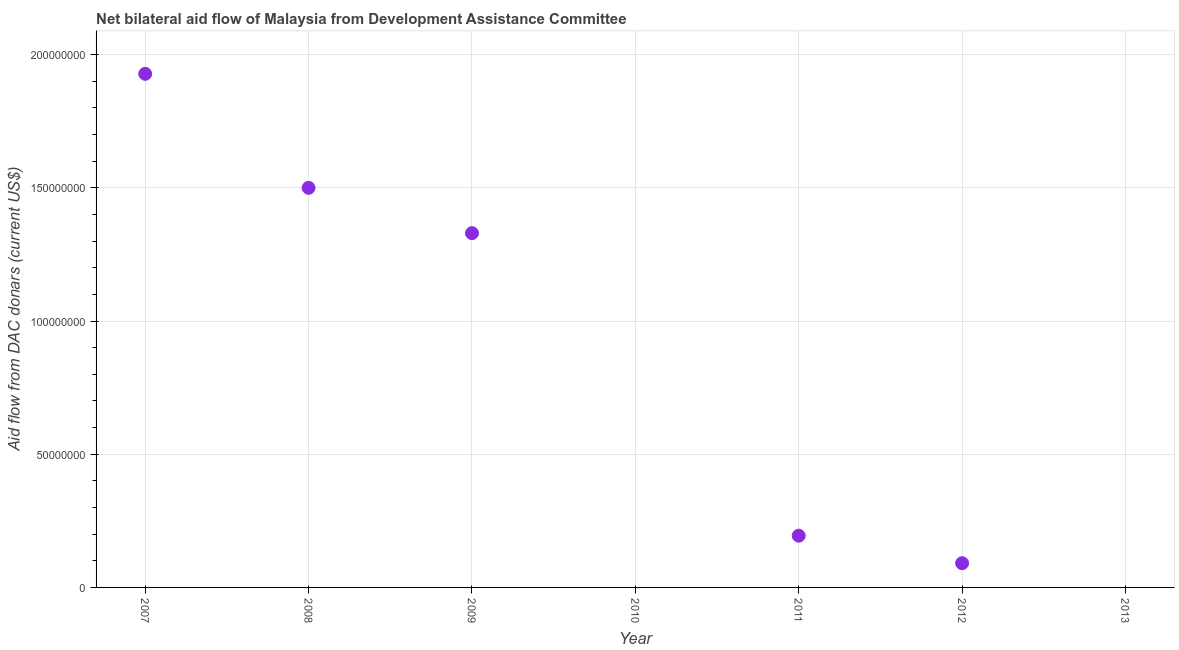What is the net bilateral aid flows from dac donors in 2007?
Ensure brevity in your answer.  1.93e+08. Across all years, what is the maximum net bilateral aid flows from dac donors?
Provide a succinct answer. 1.93e+08. Across all years, what is the minimum net bilateral aid flows from dac donors?
Your answer should be compact. 0. What is the sum of the net bilateral aid flows from dac donors?
Ensure brevity in your answer.  5.04e+08. What is the difference between the net bilateral aid flows from dac donors in 2008 and 2009?
Offer a terse response. 1.70e+07. What is the average net bilateral aid flows from dac donors per year?
Your answer should be compact. 7.20e+07. What is the median net bilateral aid flows from dac donors?
Your answer should be compact. 1.94e+07. What is the difference between the highest and the second highest net bilateral aid flows from dac donors?
Provide a succinct answer. 4.28e+07. Is the sum of the net bilateral aid flows from dac donors in 2007 and 2008 greater than the maximum net bilateral aid flows from dac donors across all years?
Make the answer very short. Yes. What is the difference between the highest and the lowest net bilateral aid flows from dac donors?
Provide a short and direct response. 1.93e+08. Does the net bilateral aid flows from dac donors monotonically increase over the years?
Offer a very short reply. No. How many dotlines are there?
Provide a short and direct response. 1. How many years are there in the graph?
Your answer should be very brief. 7. What is the difference between two consecutive major ticks on the Y-axis?
Your response must be concise. 5.00e+07. Does the graph contain grids?
Offer a terse response. Yes. What is the title of the graph?
Your response must be concise. Net bilateral aid flow of Malaysia from Development Assistance Committee. What is the label or title of the Y-axis?
Your response must be concise. Aid flow from DAC donars (current US$). What is the Aid flow from DAC donars (current US$) in 2007?
Make the answer very short. 1.93e+08. What is the Aid flow from DAC donars (current US$) in 2008?
Ensure brevity in your answer.  1.50e+08. What is the Aid flow from DAC donars (current US$) in 2009?
Your answer should be compact. 1.33e+08. What is the Aid flow from DAC donars (current US$) in 2010?
Your answer should be compact. 0. What is the Aid flow from DAC donars (current US$) in 2011?
Provide a succinct answer. 1.94e+07. What is the Aid flow from DAC donars (current US$) in 2012?
Ensure brevity in your answer.  9.09e+06. What is the Aid flow from DAC donars (current US$) in 2013?
Provide a short and direct response. 0. What is the difference between the Aid flow from DAC donars (current US$) in 2007 and 2008?
Your response must be concise. 4.28e+07. What is the difference between the Aid flow from DAC donars (current US$) in 2007 and 2009?
Give a very brief answer. 5.98e+07. What is the difference between the Aid flow from DAC donars (current US$) in 2007 and 2011?
Give a very brief answer. 1.73e+08. What is the difference between the Aid flow from DAC donars (current US$) in 2007 and 2012?
Ensure brevity in your answer.  1.84e+08. What is the difference between the Aid flow from DAC donars (current US$) in 2008 and 2009?
Give a very brief answer. 1.70e+07. What is the difference between the Aid flow from DAC donars (current US$) in 2008 and 2011?
Your answer should be compact. 1.31e+08. What is the difference between the Aid flow from DAC donars (current US$) in 2008 and 2012?
Your answer should be compact. 1.41e+08. What is the difference between the Aid flow from DAC donars (current US$) in 2009 and 2011?
Provide a succinct answer. 1.14e+08. What is the difference between the Aid flow from DAC donars (current US$) in 2009 and 2012?
Give a very brief answer. 1.24e+08. What is the difference between the Aid flow from DAC donars (current US$) in 2011 and 2012?
Provide a succinct answer. 1.03e+07. What is the ratio of the Aid flow from DAC donars (current US$) in 2007 to that in 2008?
Your response must be concise. 1.28. What is the ratio of the Aid flow from DAC donars (current US$) in 2007 to that in 2009?
Offer a terse response. 1.45. What is the ratio of the Aid flow from DAC donars (current US$) in 2007 to that in 2011?
Keep it short and to the point. 9.93. What is the ratio of the Aid flow from DAC donars (current US$) in 2007 to that in 2012?
Your response must be concise. 21.21. What is the ratio of the Aid flow from DAC donars (current US$) in 2008 to that in 2009?
Your response must be concise. 1.13. What is the ratio of the Aid flow from DAC donars (current US$) in 2008 to that in 2011?
Your answer should be compact. 7.72. What is the ratio of the Aid flow from DAC donars (current US$) in 2008 to that in 2012?
Provide a short and direct response. 16.5. What is the ratio of the Aid flow from DAC donars (current US$) in 2009 to that in 2011?
Provide a succinct answer. 6.85. What is the ratio of the Aid flow from DAC donars (current US$) in 2009 to that in 2012?
Provide a succinct answer. 14.63. What is the ratio of the Aid flow from DAC donars (current US$) in 2011 to that in 2012?
Provide a succinct answer. 2.14. 